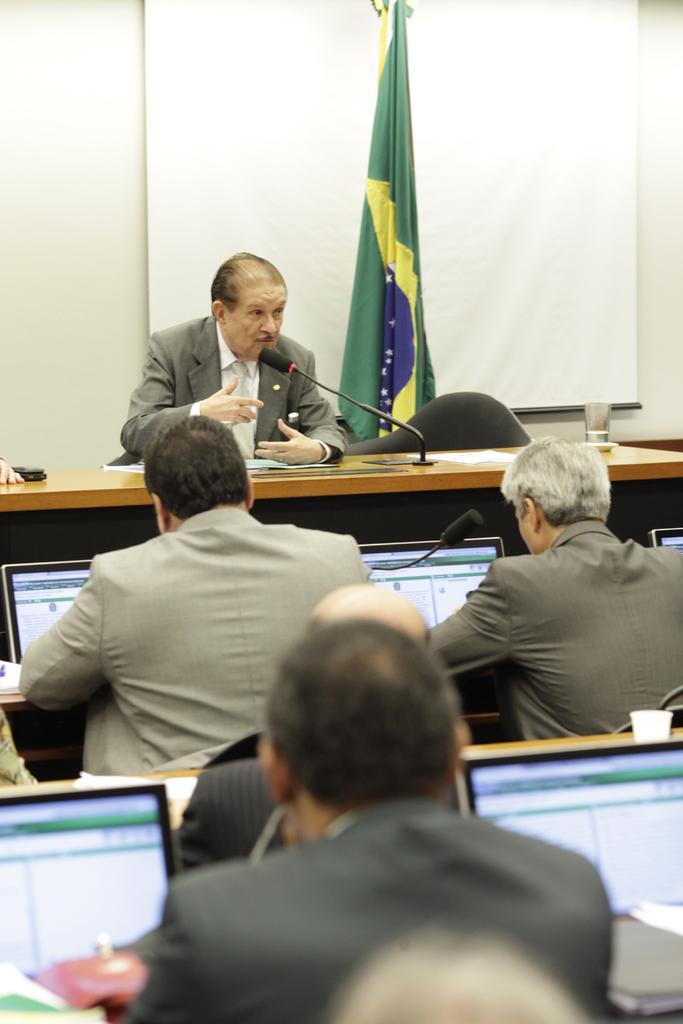Describe this image in one or two sentences. This Picture describe about four person in room in which first person is giving a speech in a microphone, beside him there is green color flag and behind a projector screen. In front person wearing a grey color coat is doing some work in computer and behind one is setting and listing to the person who is giving a speech. 